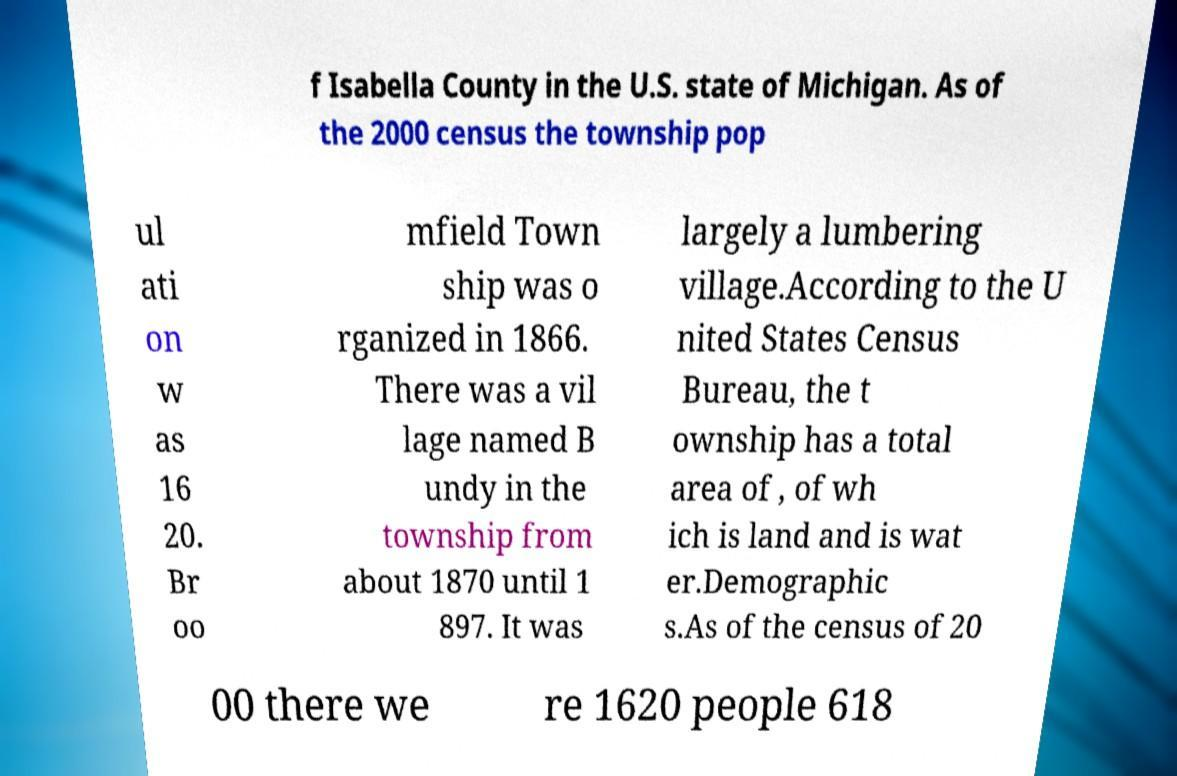Can you read and provide the text displayed in the image?This photo seems to have some interesting text. Can you extract and type it out for me? f Isabella County in the U.S. state of Michigan. As of the 2000 census the township pop ul ati on w as 16 20. Br oo mfield Town ship was o rganized in 1866. There was a vil lage named B undy in the township from about 1870 until 1 897. It was largely a lumbering village.According to the U nited States Census Bureau, the t ownship has a total area of , of wh ich is land and is wat er.Demographic s.As of the census of 20 00 there we re 1620 people 618 